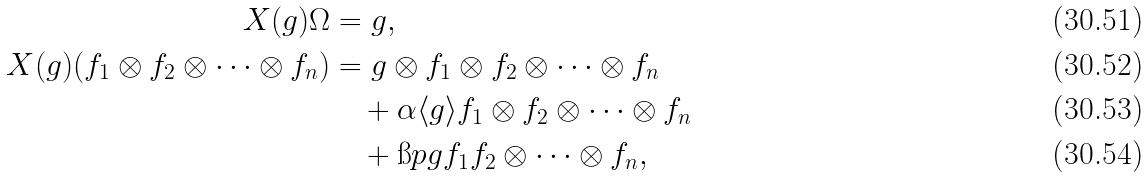Convert formula to latex. <formula><loc_0><loc_0><loc_500><loc_500>X ( g ) \Omega & = g , \\ X ( g ) ( f _ { 1 } \otimes f _ { 2 } \otimes \dots \otimes f _ { n } ) & = g \otimes f _ { 1 } \otimes f _ { 2 } \otimes \dots \otimes f _ { n } \\ & \quad + \alpha \langle g \rangle f _ { 1 } \otimes f _ { 2 } \otimes \dots \otimes f _ { n } \\ & \quad + \i p { g } { f _ { 1 } } f _ { 2 } \otimes \dots \otimes f _ { n } ,</formula> 